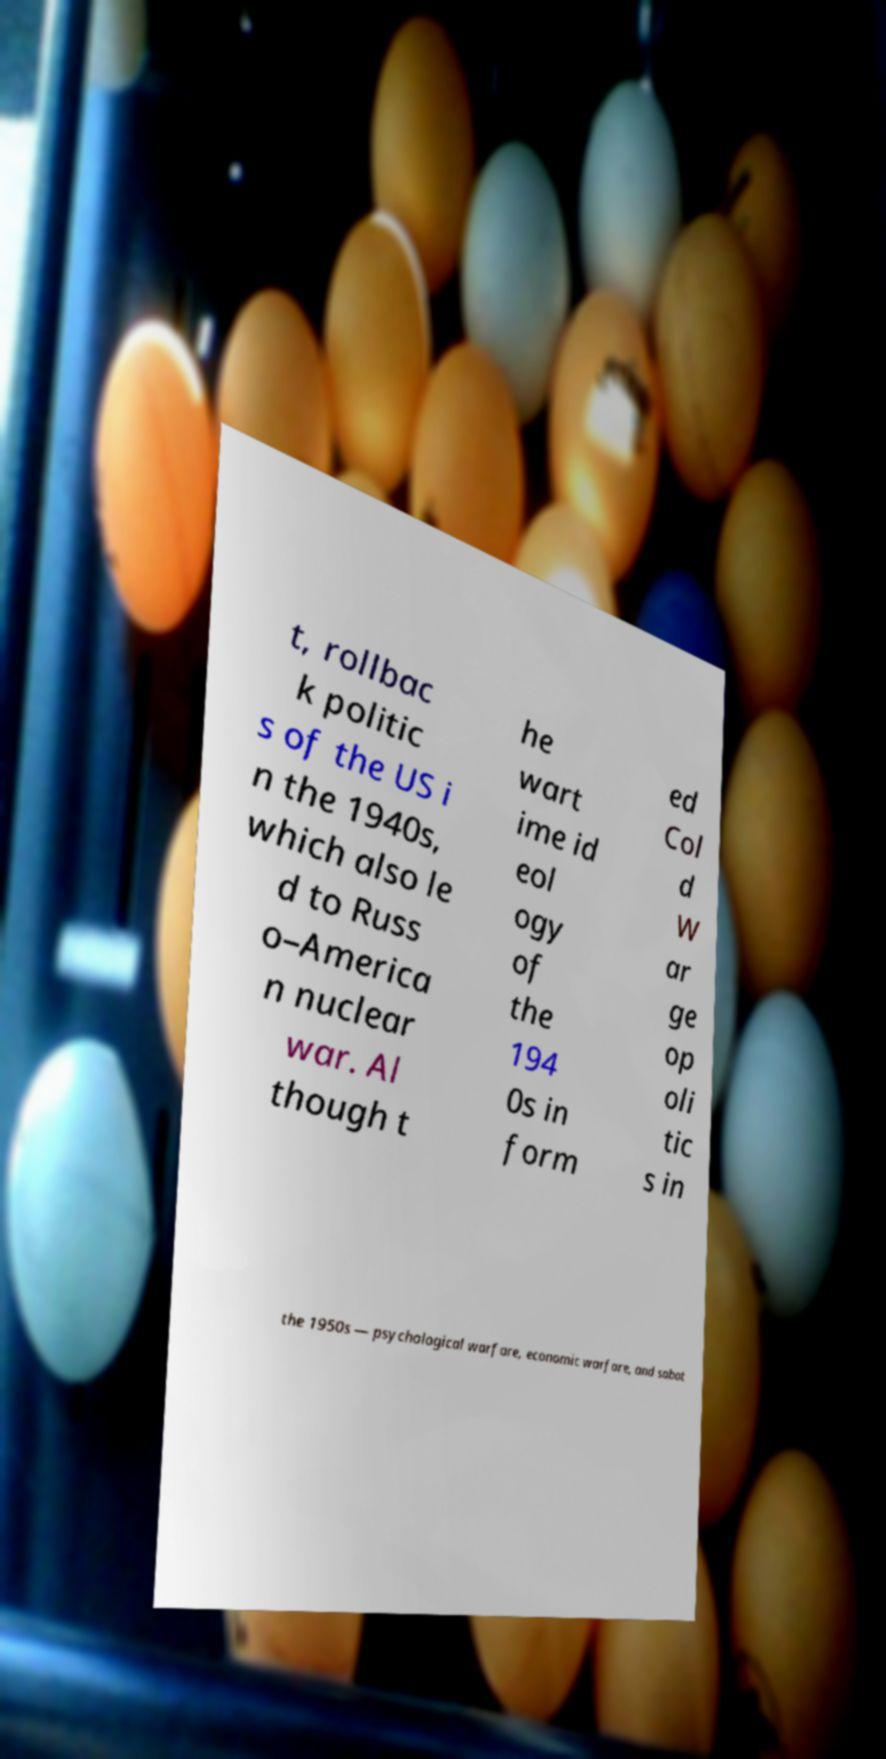Could you extract and type out the text from this image? t, rollbac k politic s of the US i n the 1940s, which also le d to Russ o–America n nuclear war. Al though t he wart ime id eol ogy of the 194 0s in form ed Col d W ar ge op oli tic s in the 1950s — psychological warfare, economic warfare, and sabot 